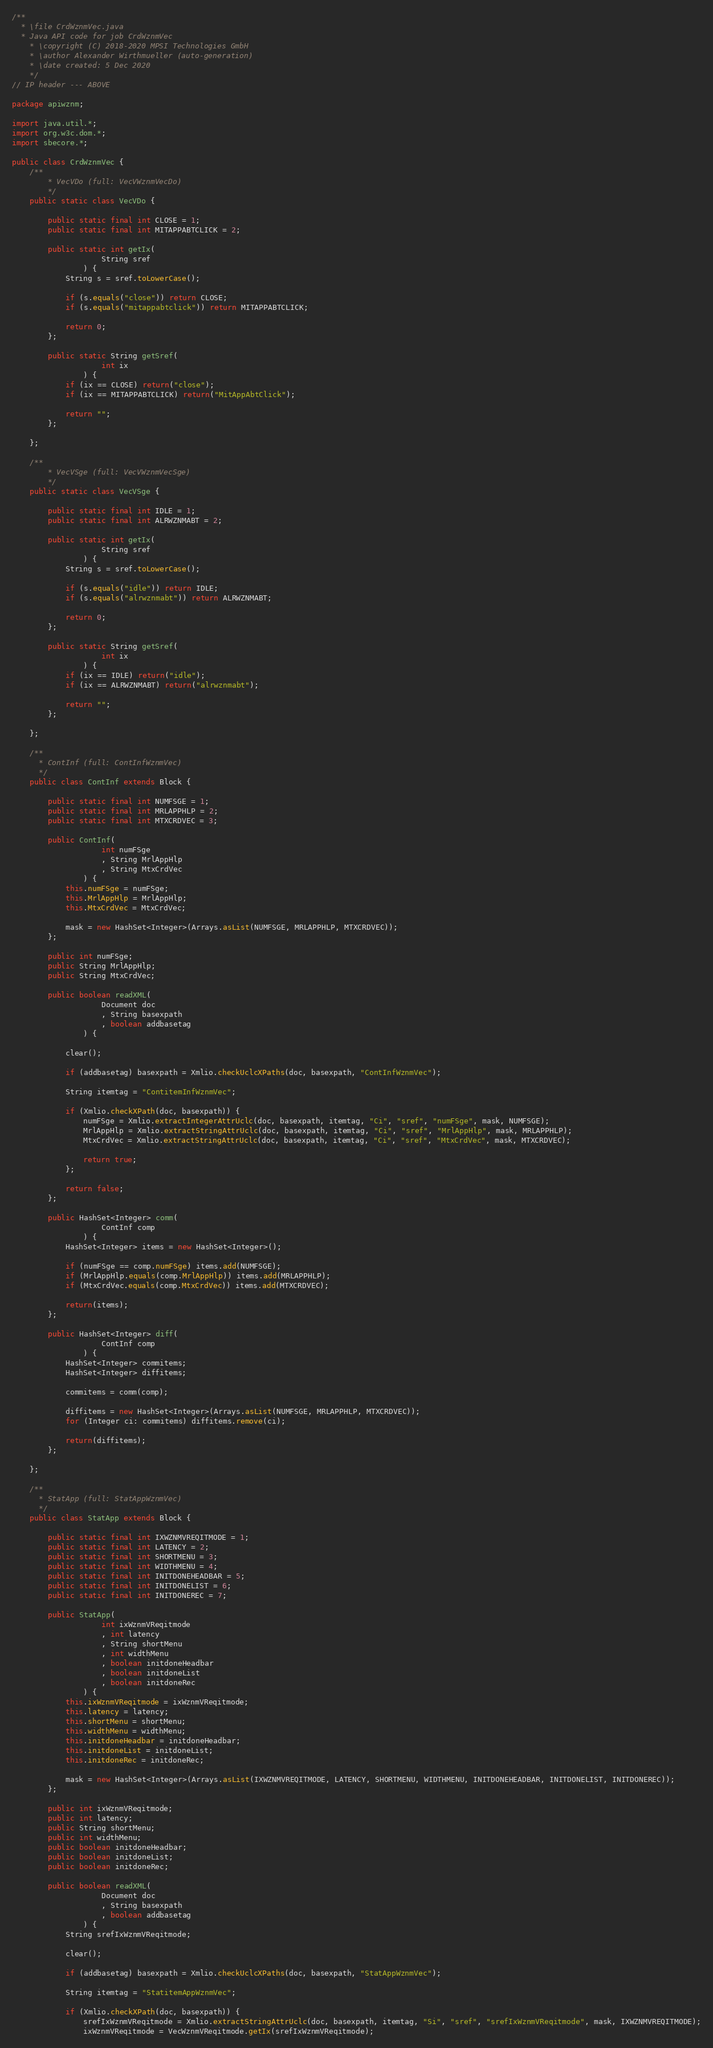Convert code to text. <code><loc_0><loc_0><loc_500><loc_500><_Java_>/**
  * \file CrdWznmVec.java
  * Java API code for job CrdWznmVec
	* \copyright (C) 2018-2020 MPSI Technologies GmbH
	* \author Alexander Wirthmueller (auto-generation)
	* \date created: 5 Dec 2020
	*/
// IP header --- ABOVE

package apiwznm;

import java.util.*;
import org.w3c.dom.*;
import sbecore.*;

public class CrdWznmVec {
	/**
		* VecVDo (full: VecVWznmVecDo)
		*/
	public static class VecVDo {

		public static final int CLOSE = 1;
		public static final int MITAPPABTCLICK = 2;

		public static int getIx(
					String sref
				) {
			String s = sref.toLowerCase();

			if (s.equals("close")) return CLOSE;
			if (s.equals("mitappabtclick")) return MITAPPABTCLICK;

			return 0;
		};

		public static String getSref(
					int ix
				) {
			if (ix == CLOSE) return("close");
			if (ix == MITAPPABTCLICK) return("MitAppAbtClick");

			return "";
		};

	};

	/**
		* VecVSge (full: VecVWznmVecSge)
		*/
	public static class VecVSge {

		public static final int IDLE = 1;
		public static final int ALRWZNMABT = 2;

		public static int getIx(
					String sref
				) {
			String s = sref.toLowerCase();

			if (s.equals("idle")) return IDLE;
			if (s.equals("alrwznmabt")) return ALRWZNMABT;

			return 0;
		};

		public static String getSref(
					int ix
				) {
			if (ix == IDLE) return("idle");
			if (ix == ALRWZNMABT) return("alrwznmabt");

			return "";
		};

	};

	/**
	  * ContInf (full: ContInfWznmVec)
	  */
	public class ContInf extends Block {

		public static final int NUMFSGE = 1;
		public static final int MRLAPPHLP = 2;
		public static final int MTXCRDVEC = 3;

		public ContInf(
					int numFSge
					, String MrlAppHlp
					, String MtxCrdVec
				) {
			this.numFSge = numFSge;
			this.MrlAppHlp = MrlAppHlp;
			this.MtxCrdVec = MtxCrdVec;

			mask = new HashSet<Integer>(Arrays.asList(NUMFSGE, MRLAPPHLP, MTXCRDVEC));
		};

		public int numFSge;
		public String MrlAppHlp;
		public String MtxCrdVec;

		public boolean readXML(
					Document doc
					, String basexpath
					, boolean addbasetag
				) {

			clear();

			if (addbasetag) basexpath = Xmlio.checkUclcXPaths(doc, basexpath, "ContInfWznmVec");

			String itemtag = "ContitemInfWznmVec";

			if (Xmlio.checkXPath(doc, basexpath)) {
				numFSge = Xmlio.extractIntegerAttrUclc(doc, basexpath, itemtag, "Ci", "sref", "numFSge", mask, NUMFSGE);
				MrlAppHlp = Xmlio.extractStringAttrUclc(doc, basexpath, itemtag, "Ci", "sref", "MrlAppHlp", mask, MRLAPPHLP);
				MtxCrdVec = Xmlio.extractStringAttrUclc(doc, basexpath, itemtag, "Ci", "sref", "MtxCrdVec", mask, MTXCRDVEC);

				return true;
			};

			return false;
		};

		public HashSet<Integer> comm(
					ContInf comp
				) {
			HashSet<Integer> items = new HashSet<Integer>();

			if (numFSge == comp.numFSge) items.add(NUMFSGE);
			if (MrlAppHlp.equals(comp.MrlAppHlp)) items.add(MRLAPPHLP);
			if (MtxCrdVec.equals(comp.MtxCrdVec)) items.add(MTXCRDVEC);

			return(items);
		};

		public HashSet<Integer> diff(
					ContInf comp
				) {
			HashSet<Integer> commitems;
			HashSet<Integer> diffitems;

			commitems = comm(comp);

			diffitems = new HashSet<Integer>(Arrays.asList(NUMFSGE, MRLAPPHLP, MTXCRDVEC));
			for (Integer ci: commitems) diffitems.remove(ci);

			return(diffitems);
		};

	};

	/**
	  * StatApp (full: StatAppWznmVec)
	  */
	public class StatApp extends Block {

		public static final int IXWZNMVREQITMODE = 1;
		public static final int LATENCY = 2;
		public static final int SHORTMENU = 3;
		public static final int WIDTHMENU = 4;
		public static final int INITDONEHEADBAR = 5;
		public static final int INITDONELIST = 6;
		public static final int INITDONEREC = 7;

		public StatApp(
					int ixWznmVReqitmode
					, int latency
					, String shortMenu
					, int widthMenu
					, boolean initdoneHeadbar
					, boolean initdoneList
					, boolean initdoneRec
				) {
			this.ixWznmVReqitmode = ixWznmVReqitmode;
			this.latency = latency;
			this.shortMenu = shortMenu;
			this.widthMenu = widthMenu;
			this.initdoneHeadbar = initdoneHeadbar;
			this.initdoneList = initdoneList;
			this.initdoneRec = initdoneRec;

			mask = new HashSet<Integer>(Arrays.asList(IXWZNMVREQITMODE, LATENCY, SHORTMENU, WIDTHMENU, INITDONEHEADBAR, INITDONELIST, INITDONEREC));
		};

		public int ixWznmVReqitmode;
		public int latency;
		public String shortMenu;
		public int widthMenu;
		public boolean initdoneHeadbar;
		public boolean initdoneList;
		public boolean initdoneRec;

		public boolean readXML(
					Document doc
					, String basexpath
					, boolean addbasetag
				) {
			String srefIxWznmVReqitmode;

			clear();

			if (addbasetag) basexpath = Xmlio.checkUclcXPaths(doc, basexpath, "StatAppWznmVec");

			String itemtag = "StatitemAppWznmVec";

			if (Xmlio.checkXPath(doc, basexpath)) {
				srefIxWznmVReqitmode = Xmlio.extractStringAttrUclc(doc, basexpath, itemtag, "Si", "sref", "srefIxWznmVReqitmode", mask, IXWZNMVREQITMODE);
				ixWznmVReqitmode = VecWznmVReqitmode.getIx(srefIxWznmVReqitmode);</code> 